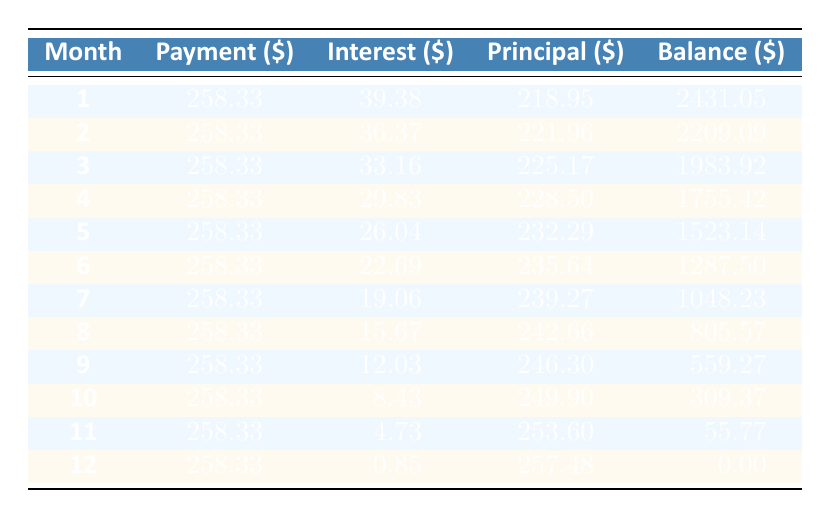What is the total credit card debt incurred from home decor products featured in "Queer Eye"? The total credit card debt is explicitly stated in the data as 2650.
Answer: 2650 How much was the interest paid in the first month? The table shows that in month 1, the interest paid is 39.38.
Answer: 39.38 What was the remaining balance after the second month? The table indicates that after month 2, the remaining balance is 2209.09.
Answer: 2209.09 What is the total principal paid over the entire payment period? The principal paid for each month can be summed up: 218.95 + 221.96 + 225.17 + 228.50 + 232.29 + 235.64 + 239.27 + 242.66 + 246.30 + 249.90 + 253.60 + 257.48 = 2831.74.
Answer: 2831.74 Did the interest paid decrease in each subsequent month? Observing the interest paid, it shows a reducing trend each month from 39.38 down to 0.85, confirming a yes.
Answer: Yes What were the principal payments in the last three months, and what was the total? The principal payments for the last three months were: 249.90 (month 10), 253.60 (month 11), and 257.48 (month 12). Adding these gives 249.90 + 253.60 + 257.48 = 760.98.
Answer: 760.98 What was the average monthly payment over the payment period? The average monthly payment is calculated by taking the total payments made divided by the number of months: 258.33 * 12 = 3100, then divide by 12 to get 258.33.
Answer: 258.33 How much was the total interest paid at the end of the payment period? Total interest can be determined by summing all monthly interest amounts: 39.38 + 36.37 + 33.16 + 29.83 + 26.04 + 22.69 + 19.06 + 15.67 + 12.03 + 8.43 + 4.73 + 0.85 =  284.69.
Answer: 284.69 What is the remaining balance after the sixth month? Referring to the table, the remaining balance after month 6 was 1287.50.
Answer: 1287.50 